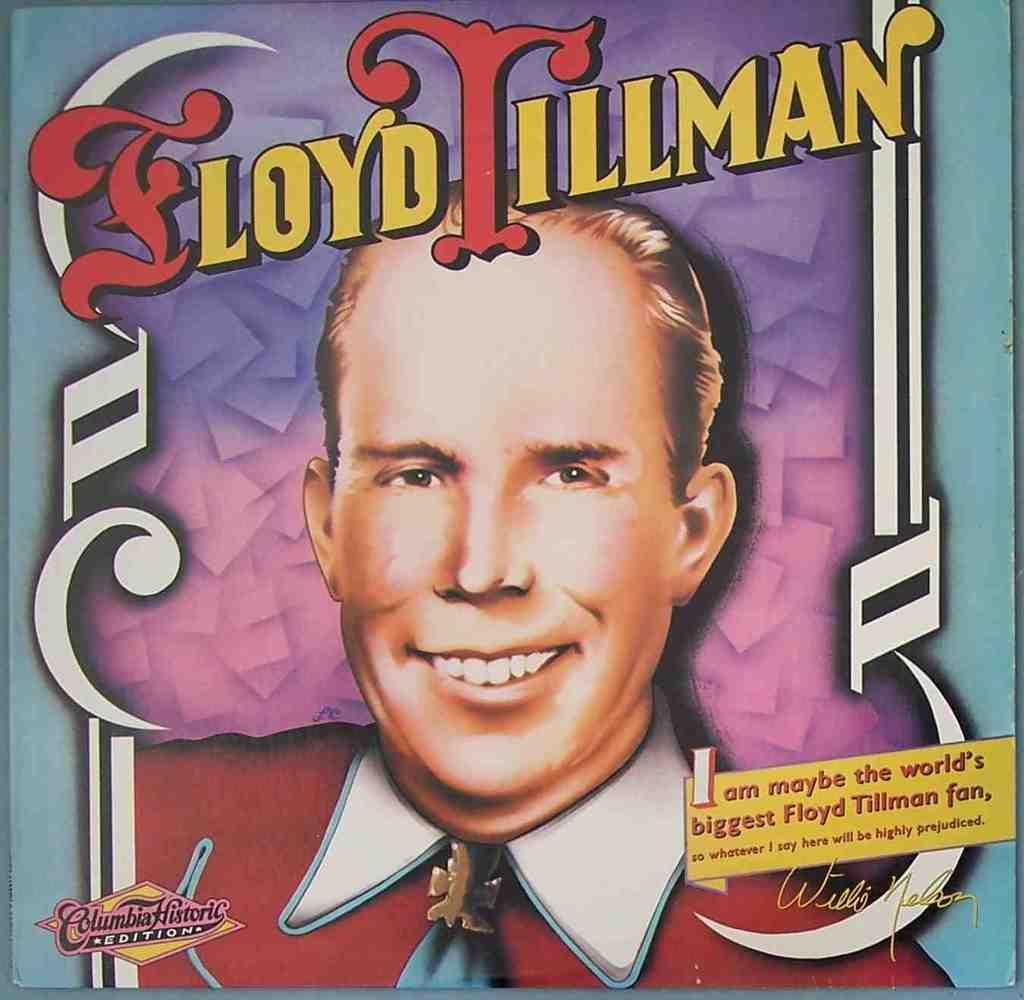What is the main subject of the image? There is a man in the image. What is the man wearing in the image? The man is wearing a red shirt. How many legs does the news have in the image? There is no news present in the image, and therefore no legs can be attributed to it. 